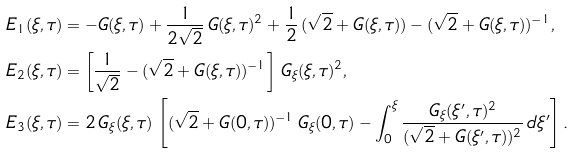Convert formula to latex. <formula><loc_0><loc_0><loc_500><loc_500>E _ { 1 } ( \xi , \tau ) & = - G ( \xi , \tau ) + \frac { 1 } { 2 \sqrt { 2 } } \, G ( \xi , \tau ) ^ { 2 } + \frac { 1 } { 2 } \, ( \sqrt { 2 } + G ( \xi , \tau ) ) - ( \sqrt { 2 } + G ( \xi , \tau ) ) ^ { - 1 } , \\ E _ { 2 } ( \xi , \tau ) & = \left [ \frac { 1 } { \sqrt { 2 } } - ( \sqrt { 2 } + G ( \xi , \tau ) ) ^ { - 1 } \right ] \, G _ { \xi } ( \xi , \tau ) ^ { 2 } , \\ E _ { 3 } ( \xi , \tau ) & = 2 \, G _ { \xi } ( \xi , \tau ) \, \left [ ( \sqrt { 2 } + G ( 0 , \tau ) ) ^ { - 1 } \, G _ { \xi } ( 0 , \tau ) - \int _ { 0 } ^ { \xi } \frac { G _ { \xi } ( \xi ^ { \prime } , \tau ) ^ { 2 } } { ( \sqrt { 2 } + G ( \xi ^ { \prime } , \tau ) ) ^ { 2 } } \, d \xi ^ { \prime } \right ] .</formula> 